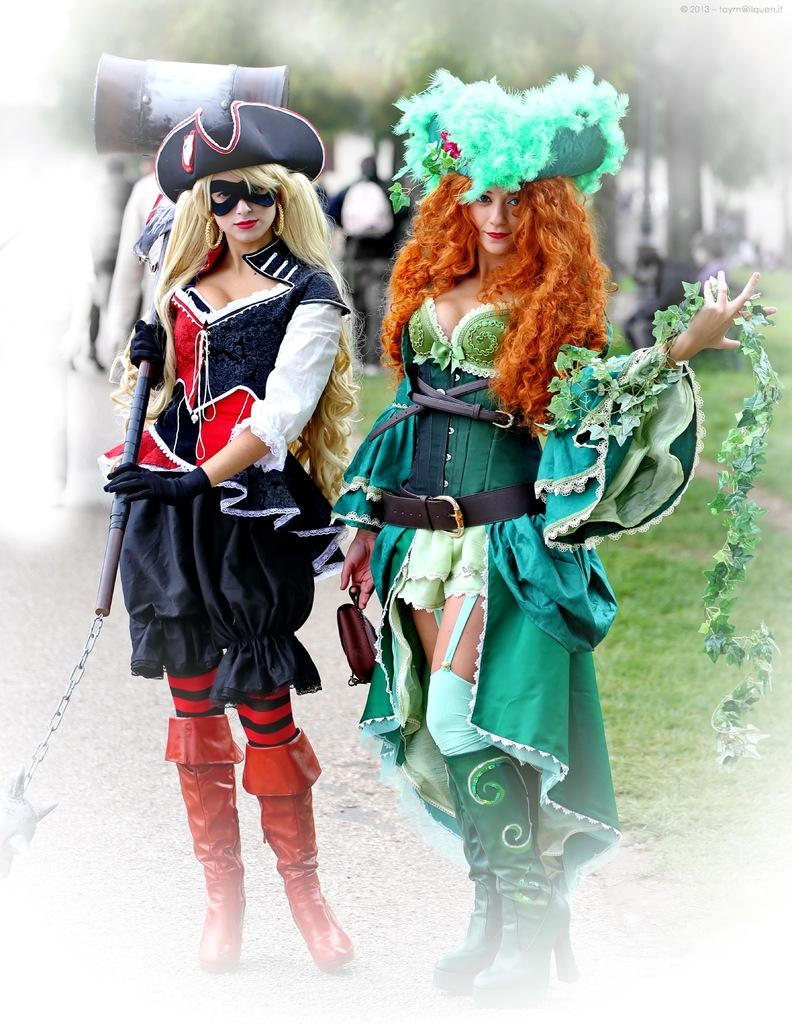How many people are in the image? There are two ladies in the image. Where are the ladies positioned in the image? The ladies are standing at the center of the image. What can be seen in the background of the image? There are trees in the background of the image. What type of vegetation is on the right side of the image? There is grass on the right side of the image. What type of punishment is being administered to the beast in the image? There is no beast present in the image, and therefore no punishment is being administered. What type of yam is being served on the plate in the image? There is no plate or yam present in the image. 